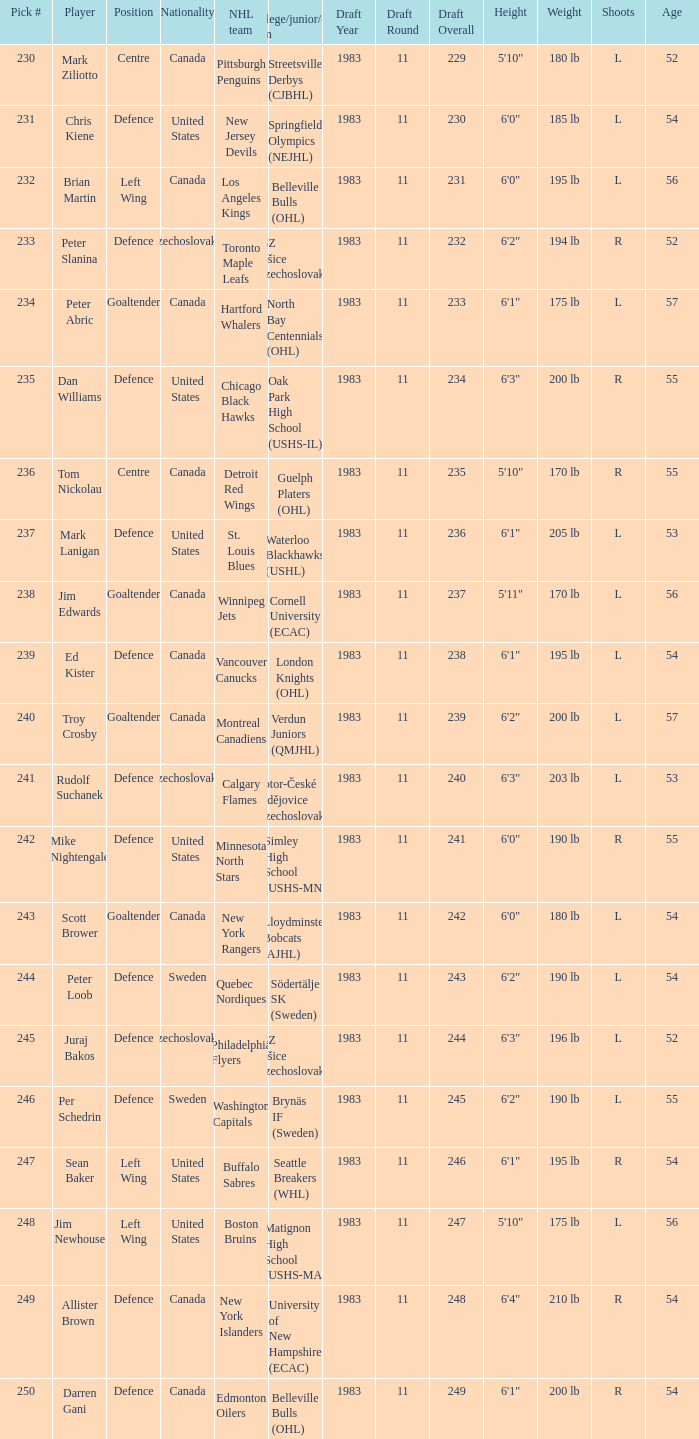Who are the members of the swedish team brynäs if? Per Schedrin. 